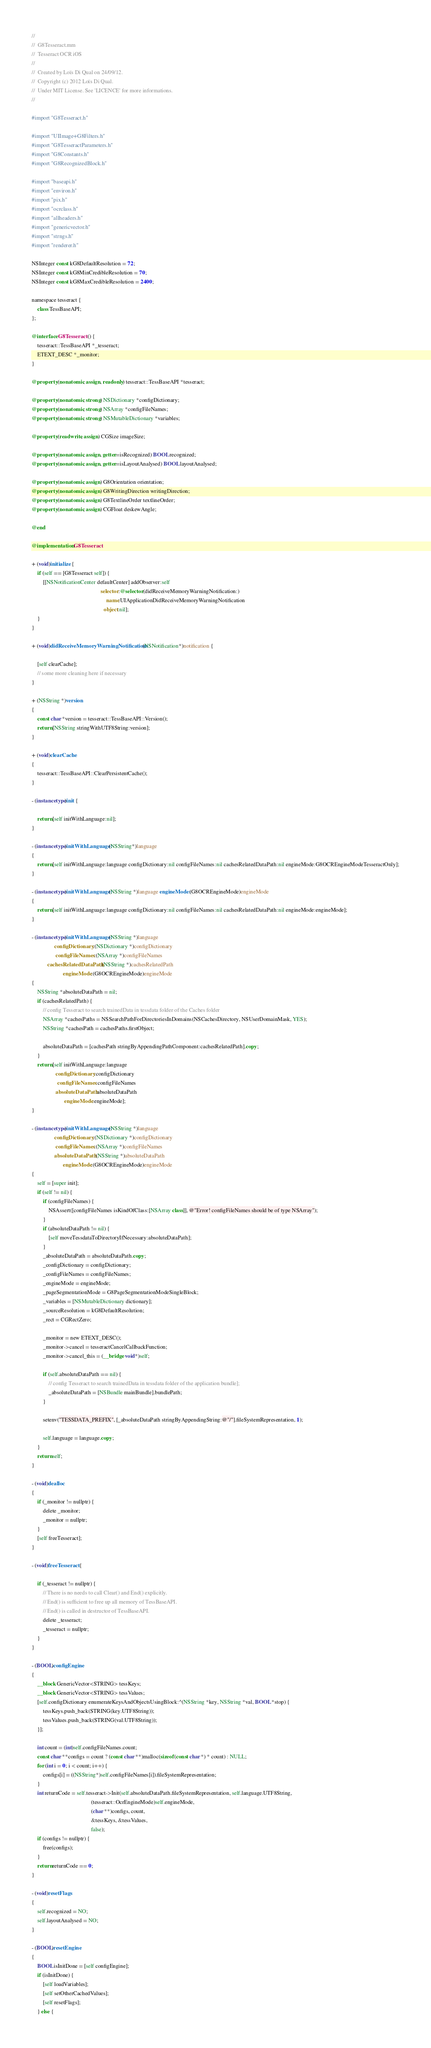<code> <loc_0><loc_0><loc_500><loc_500><_ObjectiveC_>//
//  G8Tesseract.mm
//  Tesseract OCR iOS
//
//  Created by Loïs Di Qual on 24/09/12.
//  Copyright (c) 2012 Loïs Di Qual.
//  Under MIT License. See 'LICENCE' for more informations.
//

#import "G8Tesseract.h"

#import "UIImage+G8Filters.h"
#import "G8TesseractParameters.h"
#import "G8Constants.h"
#import "G8RecognizedBlock.h"

#import "baseapi.h"
#import "environ.h"
#import "pix.h"
#import "ocrclass.h"
#import "allheaders.h"
#import "genericvector.h"
#import "strngs.h"
#import "renderer.h"

NSInteger const kG8DefaultResolution = 72;
NSInteger const kG8MinCredibleResolution = 70;
NSInteger const kG8MaxCredibleResolution = 2400;

namespace tesseract {
    class TessBaseAPI;
};

@interface G8Tesseract () {
    tesseract::TessBaseAPI *_tesseract;
    ETEXT_DESC *_monitor;
}

@property (nonatomic, assign, readonly) tesseract::TessBaseAPI *tesseract;

@property (nonatomic, strong) NSDictionary *configDictionary;
@property (nonatomic, strong) NSArray *configFileNames;
@property (nonatomic, strong) NSMutableDictionary *variables;

@property (readwrite, assign) CGSize imageSize;

@property (nonatomic, assign, getter=isRecognized) BOOL recognized;
@property (nonatomic, assign, getter=isLayoutAnalysed) BOOL layoutAnalysed;

@property (nonatomic, assign) G8Orientation orientation;
@property (nonatomic, assign) G8WritingDirection writingDirection;
@property (nonatomic, assign) G8TextlineOrder textlineOrder;
@property (nonatomic, assign) CGFloat deskewAngle;

@end

@implementation G8Tesseract

+ (void)initialize {
    if (self == [G8Tesseract self]) {
        [[NSNotificationCenter defaultCenter] addObserver:self
                                                 selector:@selector(didReceiveMemoryWarningNotification:)
                                                     name:UIApplicationDidReceiveMemoryWarningNotification
                                                   object:nil];
    }
}

+ (void)didReceiveMemoryWarningNotification:(NSNotification*)notification {
    
    [self clearCache];
    // some more cleaning here if necessary
}

+ (NSString *)version
{
    const char *version = tesseract::TessBaseAPI::Version();
    return [NSString stringWithUTF8String:version];
}

+ (void)clearCache
{
    tesseract::TessBaseAPI::ClearPersistentCache();
}

- (instancetype)init {
    
    return [self initWithLanguage:nil];
}

- (instancetype)initWithLanguage:(NSString*)language
{
    return [self initWithLanguage:language configDictionary:nil configFileNames:nil cachesRelatedDataPath:nil engineMode:G8OCREngineModeTesseractOnly];
}

- (instancetype)initWithLanguage:(NSString *)language engineMode:(G8OCREngineMode)engineMode
{
    return [self initWithLanguage:language configDictionary:nil configFileNames:nil cachesRelatedDataPath:nil engineMode:engineMode];
}

- (instancetype)initWithLanguage:(NSString *)language
                configDictionary:(NSDictionary *)configDictionary
                 configFileNames:(NSArray *)configFileNames
           cachesRelatedDataPath:(NSString *)cachesRelatedPath
                      engineMode:(G8OCREngineMode)engineMode
{
    NSString *absoluteDataPath = nil;
    if (cachesRelatedPath) {
        // config Tesseract to search trainedData in tessdata folder of the Caches folder
        NSArray *cachesPaths = NSSearchPathForDirectoriesInDomains(NSCachesDirectory, NSUserDomainMask, YES);
        NSString *cachesPath = cachesPaths.firstObject;

        absoluteDataPath = [cachesPath stringByAppendingPathComponent:cachesRelatedPath].copy;
    }
    return [self initWithLanguage:language
                 configDictionary:configDictionary
                  configFileNames:configFileNames
                 absoluteDataPath:absoluteDataPath
                       engineMode:engineMode];
}

- (instancetype)initWithLanguage:(NSString *)language
                configDictionary:(NSDictionary *)configDictionary
                 configFileNames:(NSArray *)configFileNames
                absoluteDataPath:(NSString *)absoluteDataPath
                      engineMode:(G8OCREngineMode)engineMode
{
    self = [super init];
    if (self != nil) {
        if (configFileNames) {
            NSAssert([configFileNames isKindOfClass:[NSArray class]], @"Error! configFileNames should be of type NSArray");
        }
        if (absoluteDataPath != nil) {
            [self moveTessdataToDirectoryIfNecessary:absoluteDataPath];
        }
        _absoluteDataPath = absoluteDataPath.copy;
        _configDictionary = configDictionary;
        _configFileNames = configFileNames;
        _engineMode = engineMode;
        _pageSegmentationMode = G8PageSegmentationModeSingleBlock;
        _variables = [NSMutableDictionary dictionary];
        _sourceResolution = kG8DefaultResolution;
        _rect = CGRectZero;

        _monitor = new ETEXT_DESC();
        _monitor->cancel = tesseractCancelCallbackFunction;
        _monitor->cancel_this = (__bridge void*)self;

        if (self.absoluteDataPath == nil) {
            // config Tesseract to search trainedData in tessdata folder of the application bundle];
            _absoluteDataPath = [NSBundle mainBundle].bundlePath;
        }
        
        setenv("TESSDATA_PREFIX", [_absoluteDataPath stringByAppendingString:@"/"].fileSystemRepresentation, 1);

        self.language = language.copy;
    }
    return self;
}

- (void)dealloc
{
    if (_monitor != nullptr) {
        delete _monitor;
        _monitor = nullptr;
    }
    [self freeTesseract];
}

- (void)freeTesseract {
    
    if (_tesseract != nullptr) {
        // There is no needs to call Clear() and End() explicitly.
        // End() is sufficient to free up all memory of TessBaseAPI.
        // End() is called in destructor of TessBaseAPI.
        delete _tesseract;
        _tesseract = nullptr;
    }
}

- (BOOL)configEngine
{
    __block GenericVector<STRING> tessKeys;
    __block GenericVector<STRING> tessValues;
    [self.configDictionary enumerateKeysAndObjectsUsingBlock:^(NSString *key, NSString *val, BOOL *stop) {
        tessKeys.push_back(STRING(key.UTF8String));
        tessValues.push_back(STRING(val.UTF8String));
    }];
    
    int count = (int)self.configFileNames.count;
    const char **configs = count ? (const char **)malloc(sizeof(const char *) * count) : NULL;
    for (int i = 0; i < count; i++) {
        configs[i] = ((NSString*)self.configFileNames[i]).fileSystemRepresentation;
    }
    int returnCode = self.tesseract->Init(self.absoluteDataPath.fileSystemRepresentation, self.language.UTF8String,
                                          (tesseract::OcrEngineMode)self.engineMode,
                                          (char **)configs, count,
                                          &tessKeys, &tessValues,
                                          false);
    if (configs != nullptr) {
        free(configs);
    }
    return returnCode == 0;
}

- (void)resetFlags
{
    self.recognized = NO;
    self.layoutAnalysed = NO;
}

- (BOOL)resetEngine
{
    BOOL isInitDone = [self configEngine];
    if (isInitDone) {
        [self loadVariables];
        [self setOtherCachedValues];
        [self resetFlags];
    } else {</code> 